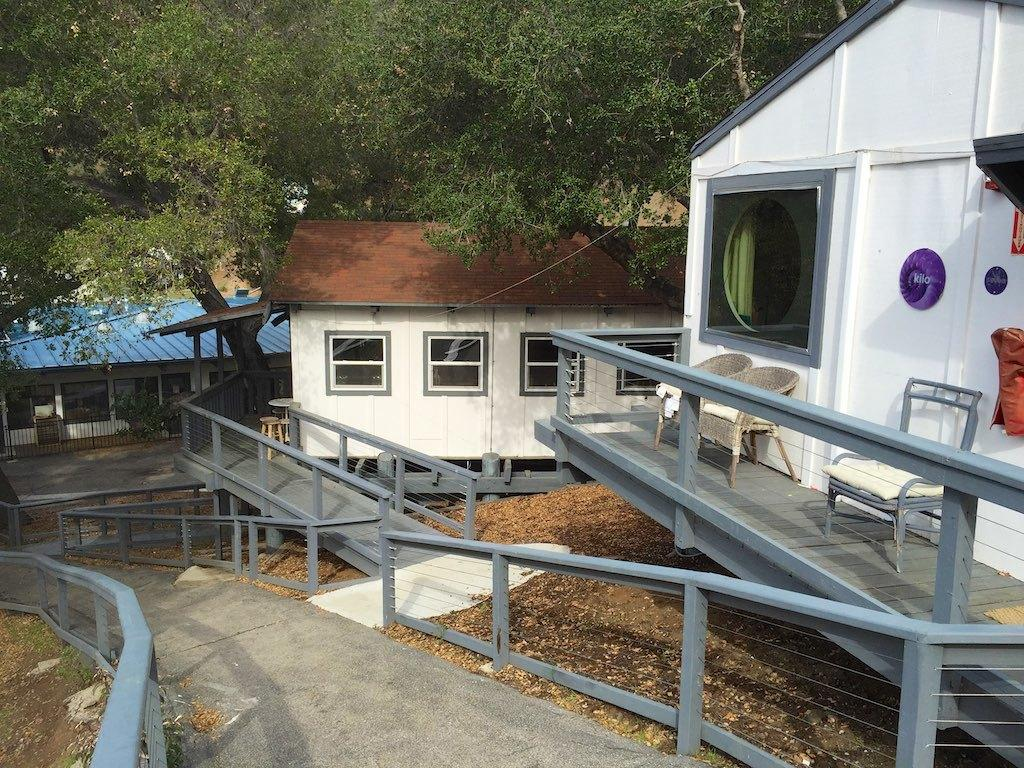What type of structures can be seen in the image? There are walkways, iron grilles, and houses in the image. What type of vegetation is present in the image? There are trees in the image. Where are the chairs located in the image? There are three chairs in the balcony. Can you see any harbors in the image? There is no harbor present in the image. What type of engine is visible in the image? There is no engine present in the image. 